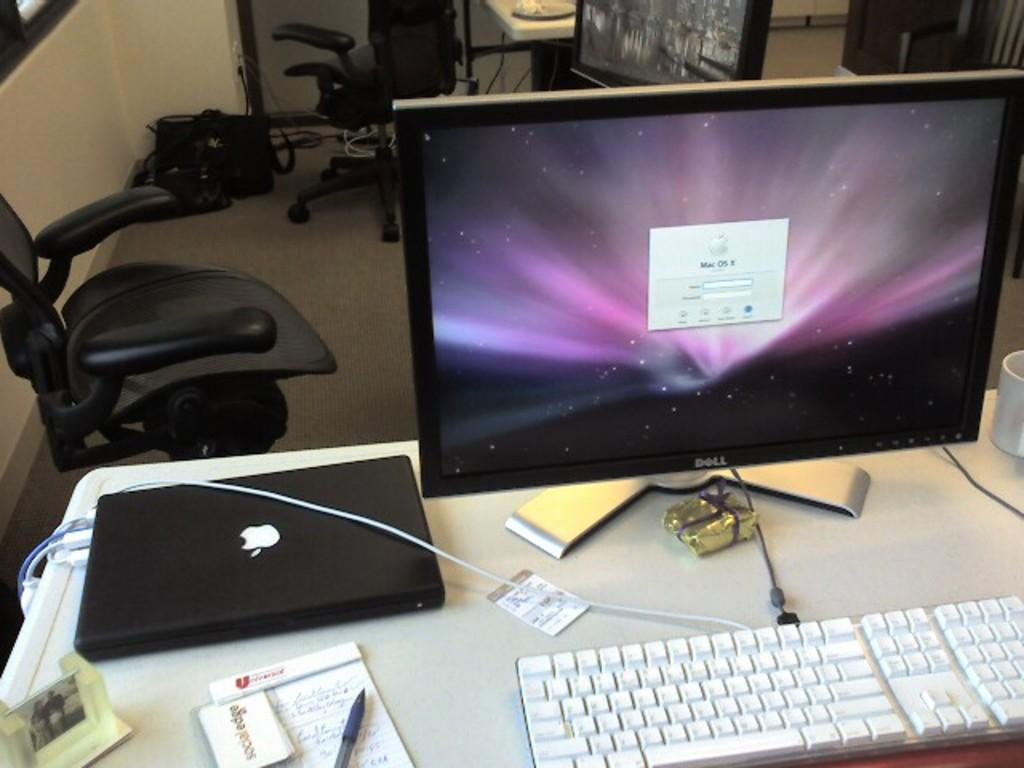<image>
Relay a brief, clear account of the picture shown. A Dell computer prompts a user to log in. 